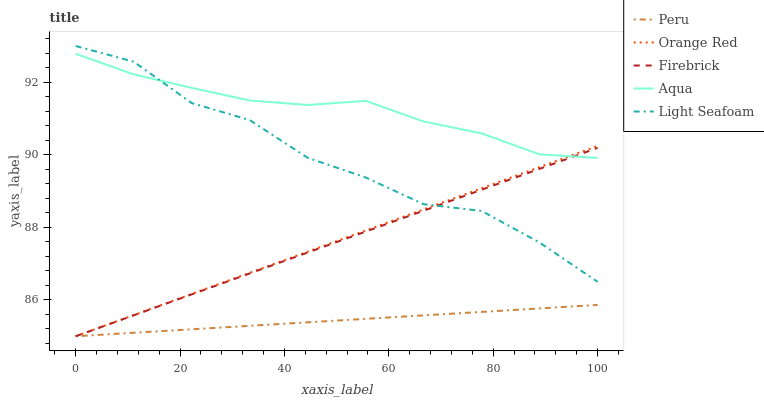Does Peru have the minimum area under the curve?
Answer yes or no. Yes. Does Aqua have the maximum area under the curve?
Answer yes or no. Yes. Does Light Seafoam have the minimum area under the curve?
Answer yes or no. No. Does Light Seafoam have the maximum area under the curve?
Answer yes or no. No. Is Firebrick the smoothest?
Answer yes or no. Yes. Is Light Seafoam the roughest?
Answer yes or no. Yes. Is Aqua the smoothest?
Answer yes or no. No. Is Aqua the roughest?
Answer yes or no. No. Does Firebrick have the lowest value?
Answer yes or no. Yes. Does Light Seafoam have the lowest value?
Answer yes or no. No. Does Light Seafoam have the highest value?
Answer yes or no. Yes. Does Aqua have the highest value?
Answer yes or no. No. Is Peru less than Light Seafoam?
Answer yes or no. Yes. Is Light Seafoam greater than Peru?
Answer yes or no. Yes. Does Aqua intersect Orange Red?
Answer yes or no. Yes. Is Aqua less than Orange Red?
Answer yes or no. No. Is Aqua greater than Orange Red?
Answer yes or no. No. Does Peru intersect Light Seafoam?
Answer yes or no. No. 